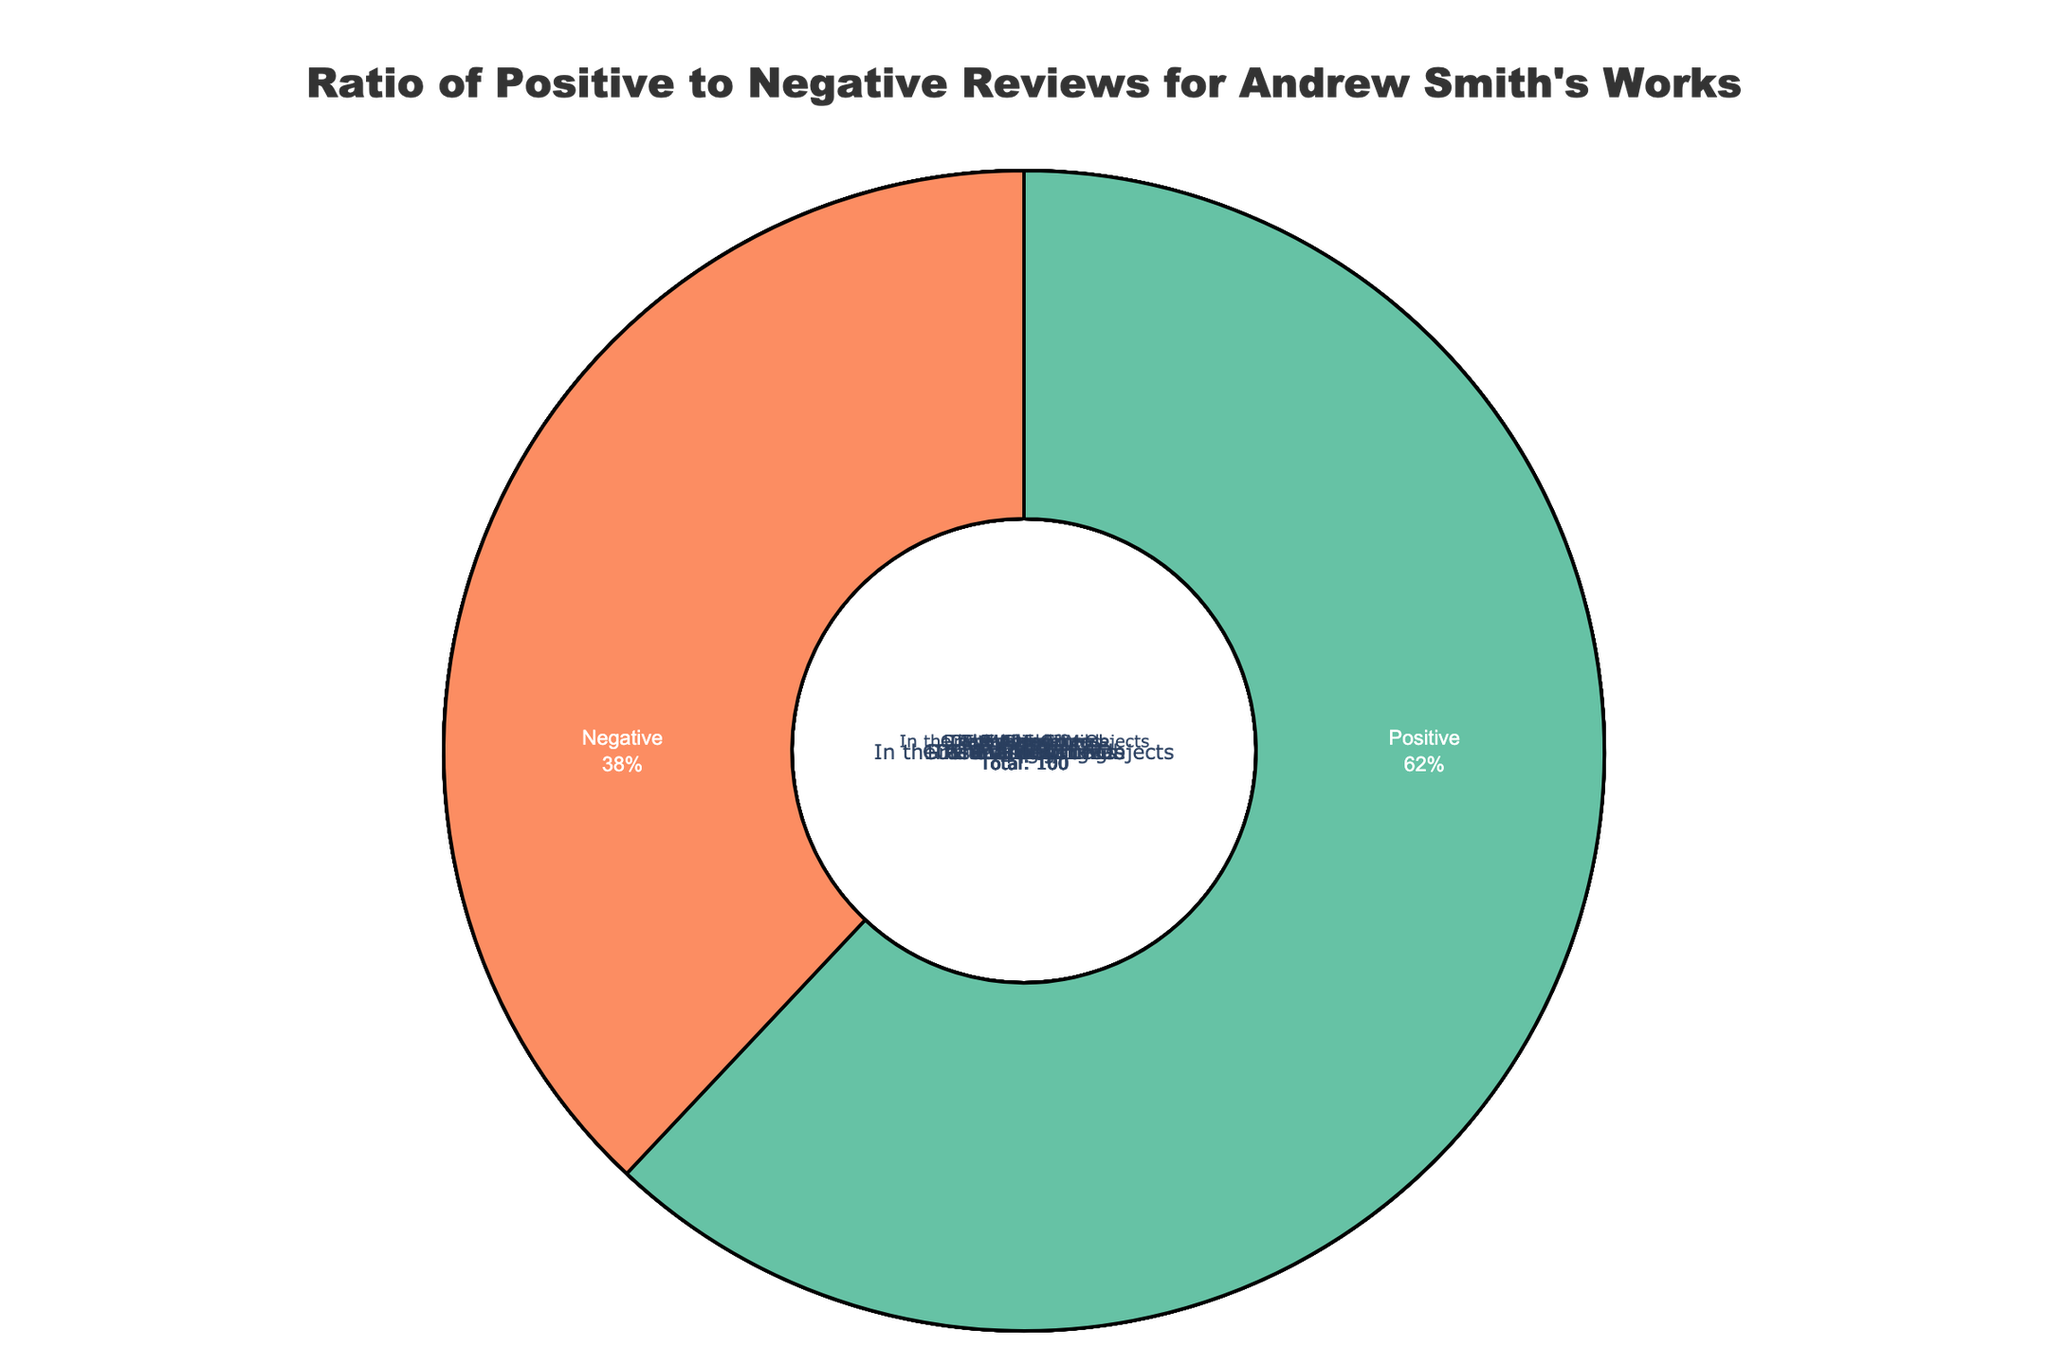Which book has the highest ratio of positive to negative reviews? Look at the percentage values in the pie slices. "Winger" has the highest ratio of positive (80%) to negative (20%) reviews.
Answer: Winger Which book has the lowest ratio of positive to negative reviews? Check the books with the smallest percentage of positive reviews and the highest percentage of negative reviews. "The Alex Crow" has 55% positive and 45% negative reviews, the lowest ratio.
Answer: The Alex Crow What’s the average percentage of positive reviews across all books? Add the percentages of positive reviews for all books and divide by the number of books. The sum of positive percentages is 67.5 + 64 + 58.5 + 63.75 + 60 + 57.5 + 68 + 65 + 58.75 + 61 = 624.5. There are 10 books. So, 624.5/10 = 62.45%.
Answer: 62.45% Which book has the closest to equal proportion of positive and negative reviews? Look for the pie chart slice where the positive and negative percentages are closest to 50%. "Stand-Off" with 60% positive and 40% negative reviews is the closest to equal.
Answer: Stand-Off How much higher is the percentage of positive reviews for "Grasshopper Jungle" compared to "The Alex Crow"? Subtract the percentage of positive reviews of "The Alex Crow" from "Grasshopper Jungle". "Grasshopper Jungle" has 75%, and "The Alex Crow" has 55%. So, 75% - 55% = 20%.
Answer: 20% Which two books have the smallest difference in their positive review percentages? Look for the closest percentages. "Passenger" and "Stick" have 72% and 62% positive reviews, respectively, with a difference of 10%. This is the smallest difference.
Answer: Passenger and Stick What is the median percentage of positive reviews for Andrew Smith's books? Order the percentages: 55%, 58%, 60%, 62%, 65%, 68%, 70%, 72%, 75%, 80%. The median value, being the average of the 5th and 6th values, is (65% + 68%) / 2 = 66.5%.
Answer: 66.5% Between "Winger" and "In the Path of Falling Objects," which one has a smaller proportion of negative reviews? Compare the negative review percentages. "Winger" has 20% negative reviews, whereas "In the Path of Falling Objects" has 42%. "Winger" has a smaller proportion.
Answer: Winger 